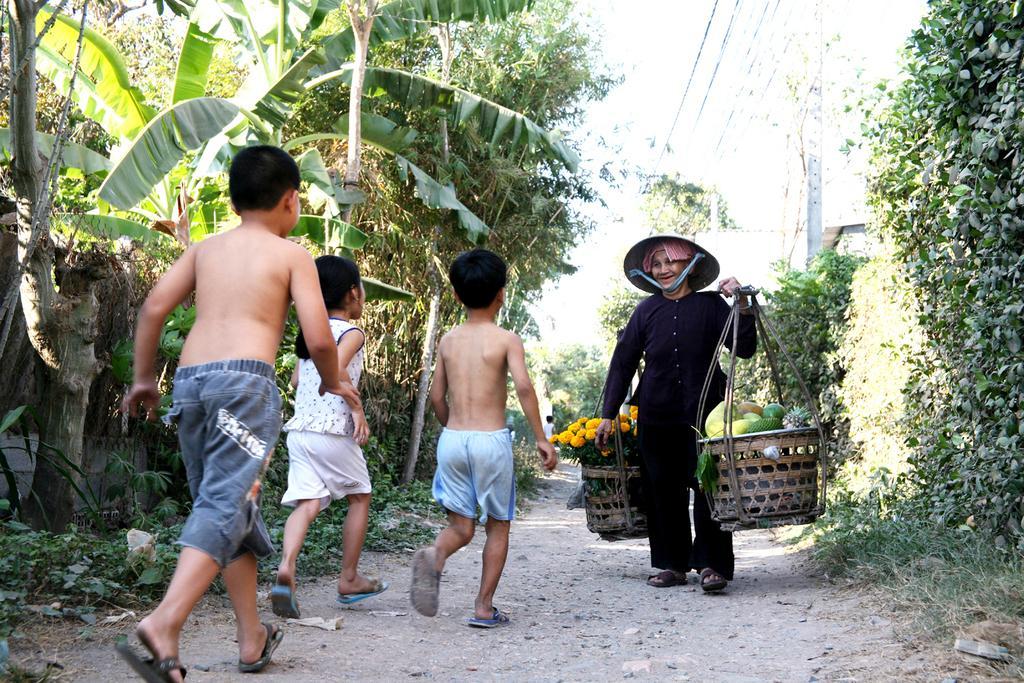In one or two sentences, can you explain what this image depicts? In the middle of the image we can see children walking on the road. In front of the children we can see a man carrying fruits in one basket and flowers in one basket on his shoulders. In the background we can see trees, walls, ground, plants, electric poles, electric cables and sky. 